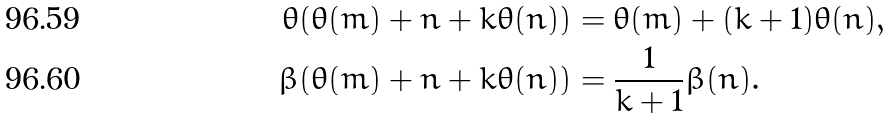Convert formula to latex. <formula><loc_0><loc_0><loc_500><loc_500>\theta ( \theta ( m ) + n + k \theta ( n ) ) & = \theta ( m ) + ( k + 1 ) \theta ( n ) , \\ \beta ( \theta ( m ) + n + k \theta ( n ) ) & = \frac { 1 } { k + 1 } \beta ( n ) .</formula> 